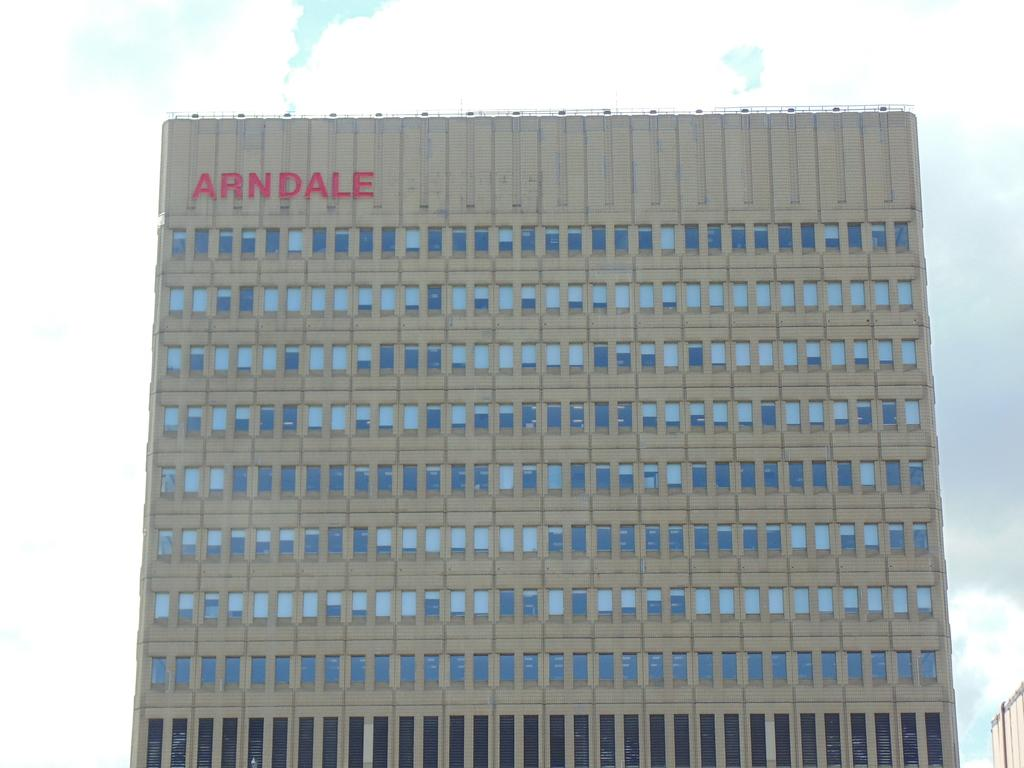What type of structure is visible in the image? There is a building in the image. What feature can be observed on the building? The building has glass windows. What is the condition of the sky in the image? The sky is covered with clouds. What type of apparatus is being used to generate a spark in the image? There is no apparatus or spark present in the image; it only features a building with glass windows and a cloudy sky. 